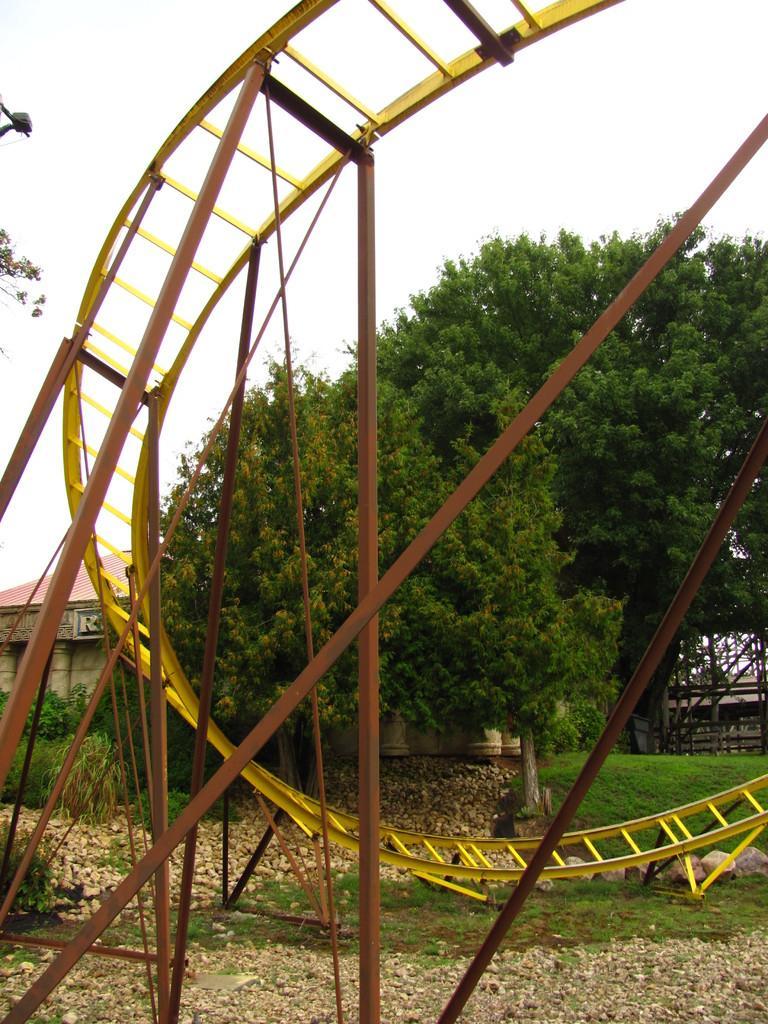Could you give a brief overview of what you see in this image? In this image there is a metal track attached to the roads which are on the land having few rocks, grass and few plants on it. Behind there are few trees and a house. Top of image there is sky. 